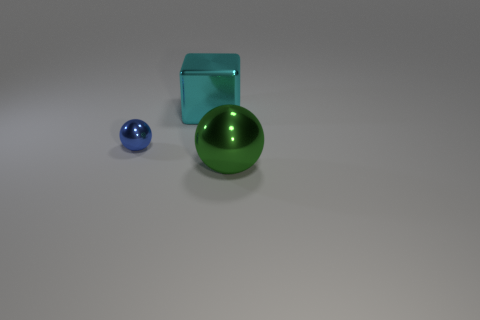Add 3 small green matte cylinders. How many objects exist? 6 Subtract all blue balls. How many balls are left? 1 Subtract all blocks. How many objects are left? 2 Subtract 1 balls. How many balls are left? 1 Subtract all purple cubes. Subtract all blue cylinders. How many cubes are left? 1 Subtract all green balls. How many red blocks are left? 0 Subtract all large brown shiny spheres. Subtract all large green metallic balls. How many objects are left? 2 Add 2 green metallic balls. How many green metallic balls are left? 3 Add 2 large green balls. How many large green balls exist? 3 Subtract 0 purple cylinders. How many objects are left? 3 